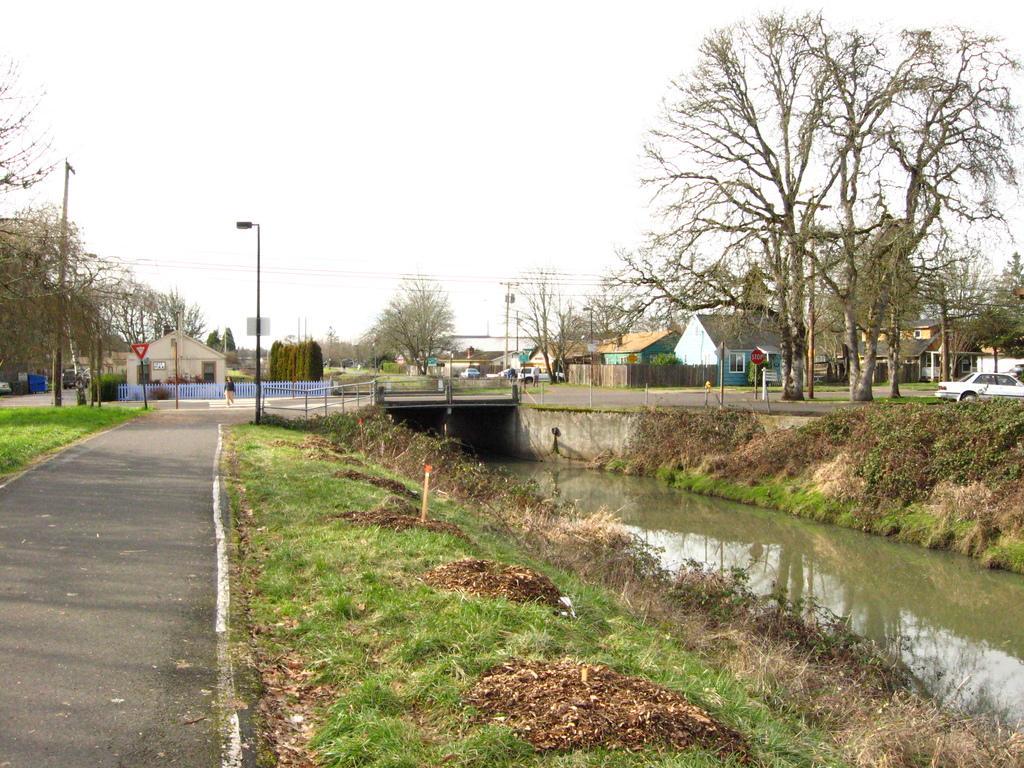Describe this image in one or two sentences. In this image I can see the road, some grass on the ground, few leaves on the ground and the water. In the background I can see few trees, few poles, the railing, the bridge, few buildings, few red colored sign boards, few vehicles and in the background I can see the sky. 